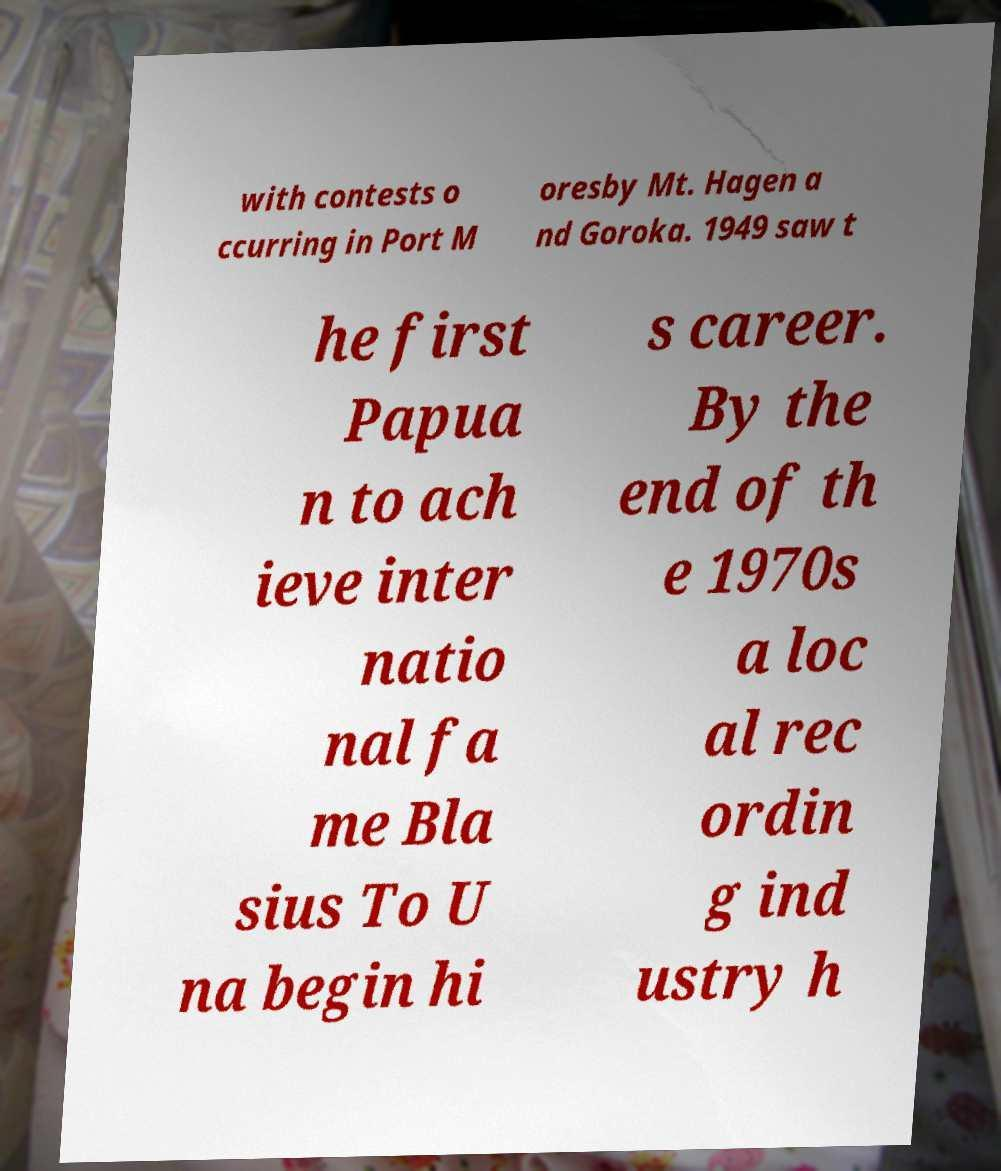Can you accurately transcribe the text from the provided image for me? with contests o ccurring in Port M oresby Mt. Hagen a nd Goroka. 1949 saw t he first Papua n to ach ieve inter natio nal fa me Bla sius To U na begin hi s career. By the end of th e 1970s a loc al rec ordin g ind ustry h 